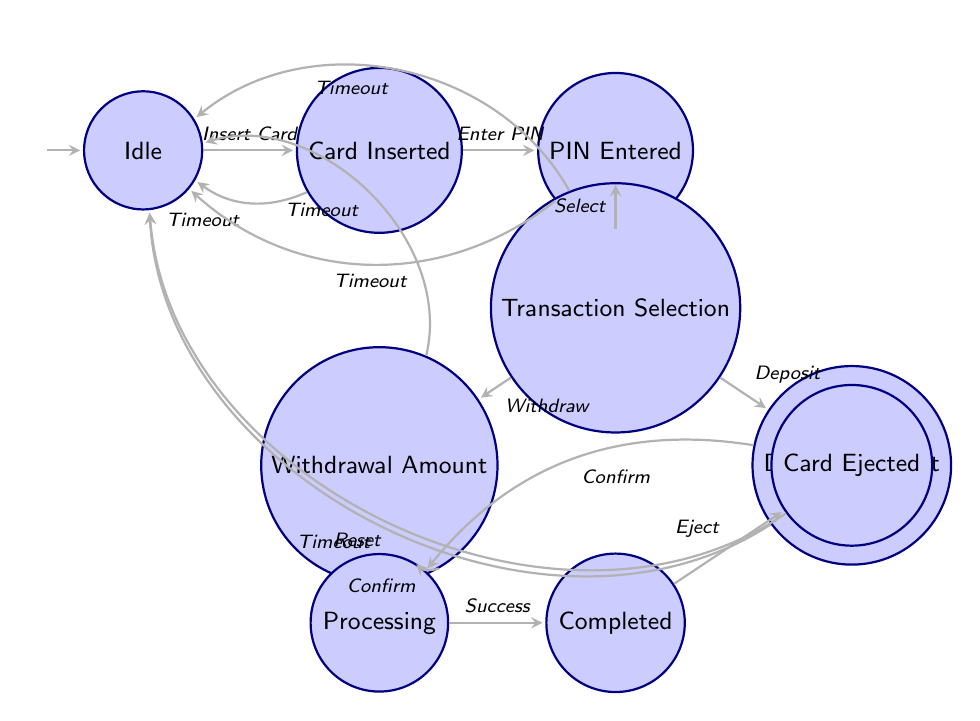What's the initial state of the ATM? The diagram indicates that the ATM starts in the "Idle" state, which is marked as the initial state.
Answer: Idle How many states are present in the diagram? Counting the states listed in the diagram, there are a total of 9 defined states.
Answer: 9 What action leads from the "Card Inserted" state to the "Pin Entered" state? The transition is labeled "Enter PIN," which indicates that this action is required to move from "Card Inserted" to "Pin Entered."
Answer: Enter PIN Which states can transition to "Idle" due to a timeout? The diagram displays multiple transitions leading back to "Idle" from "CardInserted," "PinEntered," "TransactionSelection," "WithdrawalAmountEntered," and "DepositAmountEntered" based on the timeout event.
Answer: Card Inserted, Pin Entered, Transaction Selection, Withdrawal Amount, Deposit Amount What is the final state after the transaction is completed? Upon completion of the transaction, the next state is labeled "Card Ejected," which indicates the final state of the process after a successful transaction.
Answer: Card Ejected How does the ATM process a withdrawal in the diagram? The ATM transitions from "TransactionSelection" to "Withdrawal Amount Entered" when the user selects withdrawal. Afterward, it moves to "ProcessingTransaction" upon confirming the transaction.
Answer: Processing Transaction In how many ways can the ATM go from "Withdrawal Amount Entered" to "Processing Transaction"? The transition can occur directly from "Withdrawal Amount Entered" when the user confirms the transaction, and this is the only way as per the diagram.
Answer: 1 What is the state immediately after the "Processing Transaction" state? The next state following "Processing Transaction" is "Transaction Completed," which indicates that the action has finalized successfully.
Answer: Transaction Completed Which two actions can be selected in the "Transaction Selection" state? The user has the option to select either "Withdrawal" or "Deposit" as represented by transitions branching from "Transaction Selection."
Answer: Withdrawal, Deposit 